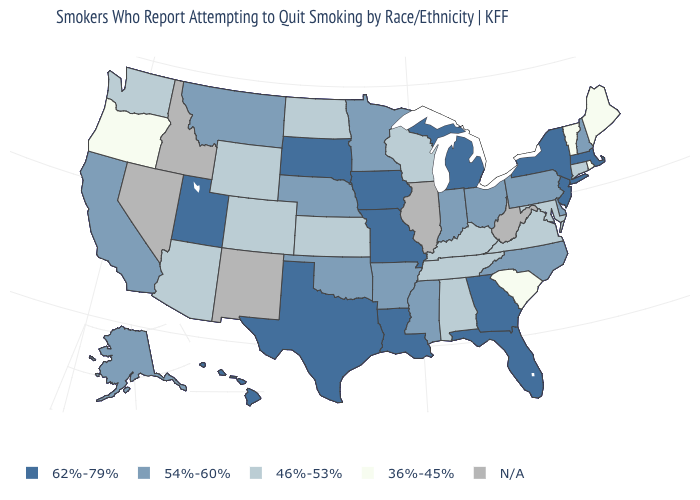Does Wisconsin have the lowest value in the MidWest?
Answer briefly. Yes. Among the states that border Oregon , which have the lowest value?
Write a very short answer. Washington. Is the legend a continuous bar?
Answer briefly. No. What is the value of New Mexico?
Be succinct. N/A. What is the value of West Virginia?
Quick response, please. N/A. What is the value of Rhode Island?
Keep it brief. 36%-45%. Among the states that border Missouri , does Kentucky have the highest value?
Quick response, please. No. Name the states that have a value in the range 62%-79%?
Be succinct. Florida, Georgia, Hawaii, Iowa, Louisiana, Massachusetts, Michigan, Missouri, New Jersey, New York, South Dakota, Texas, Utah. What is the value of Illinois?
Answer briefly. N/A. Does the map have missing data?
Concise answer only. Yes. What is the value of Virginia?
Answer briefly. 46%-53%. Name the states that have a value in the range N/A?
Write a very short answer. Idaho, Illinois, Nevada, New Mexico, West Virginia. Does Oregon have the lowest value in the West?
Be succinct. Yes. Name the states that have a value in the range 54%-60%?
Write a very short answer. Alaska, Arkansas, California, Delaware, Indiana, Minnesota, Mississippi, Montana, Nebraska, New Hampshire, North Carolina, Ohio, Oklahoma, Pennsylvania. 